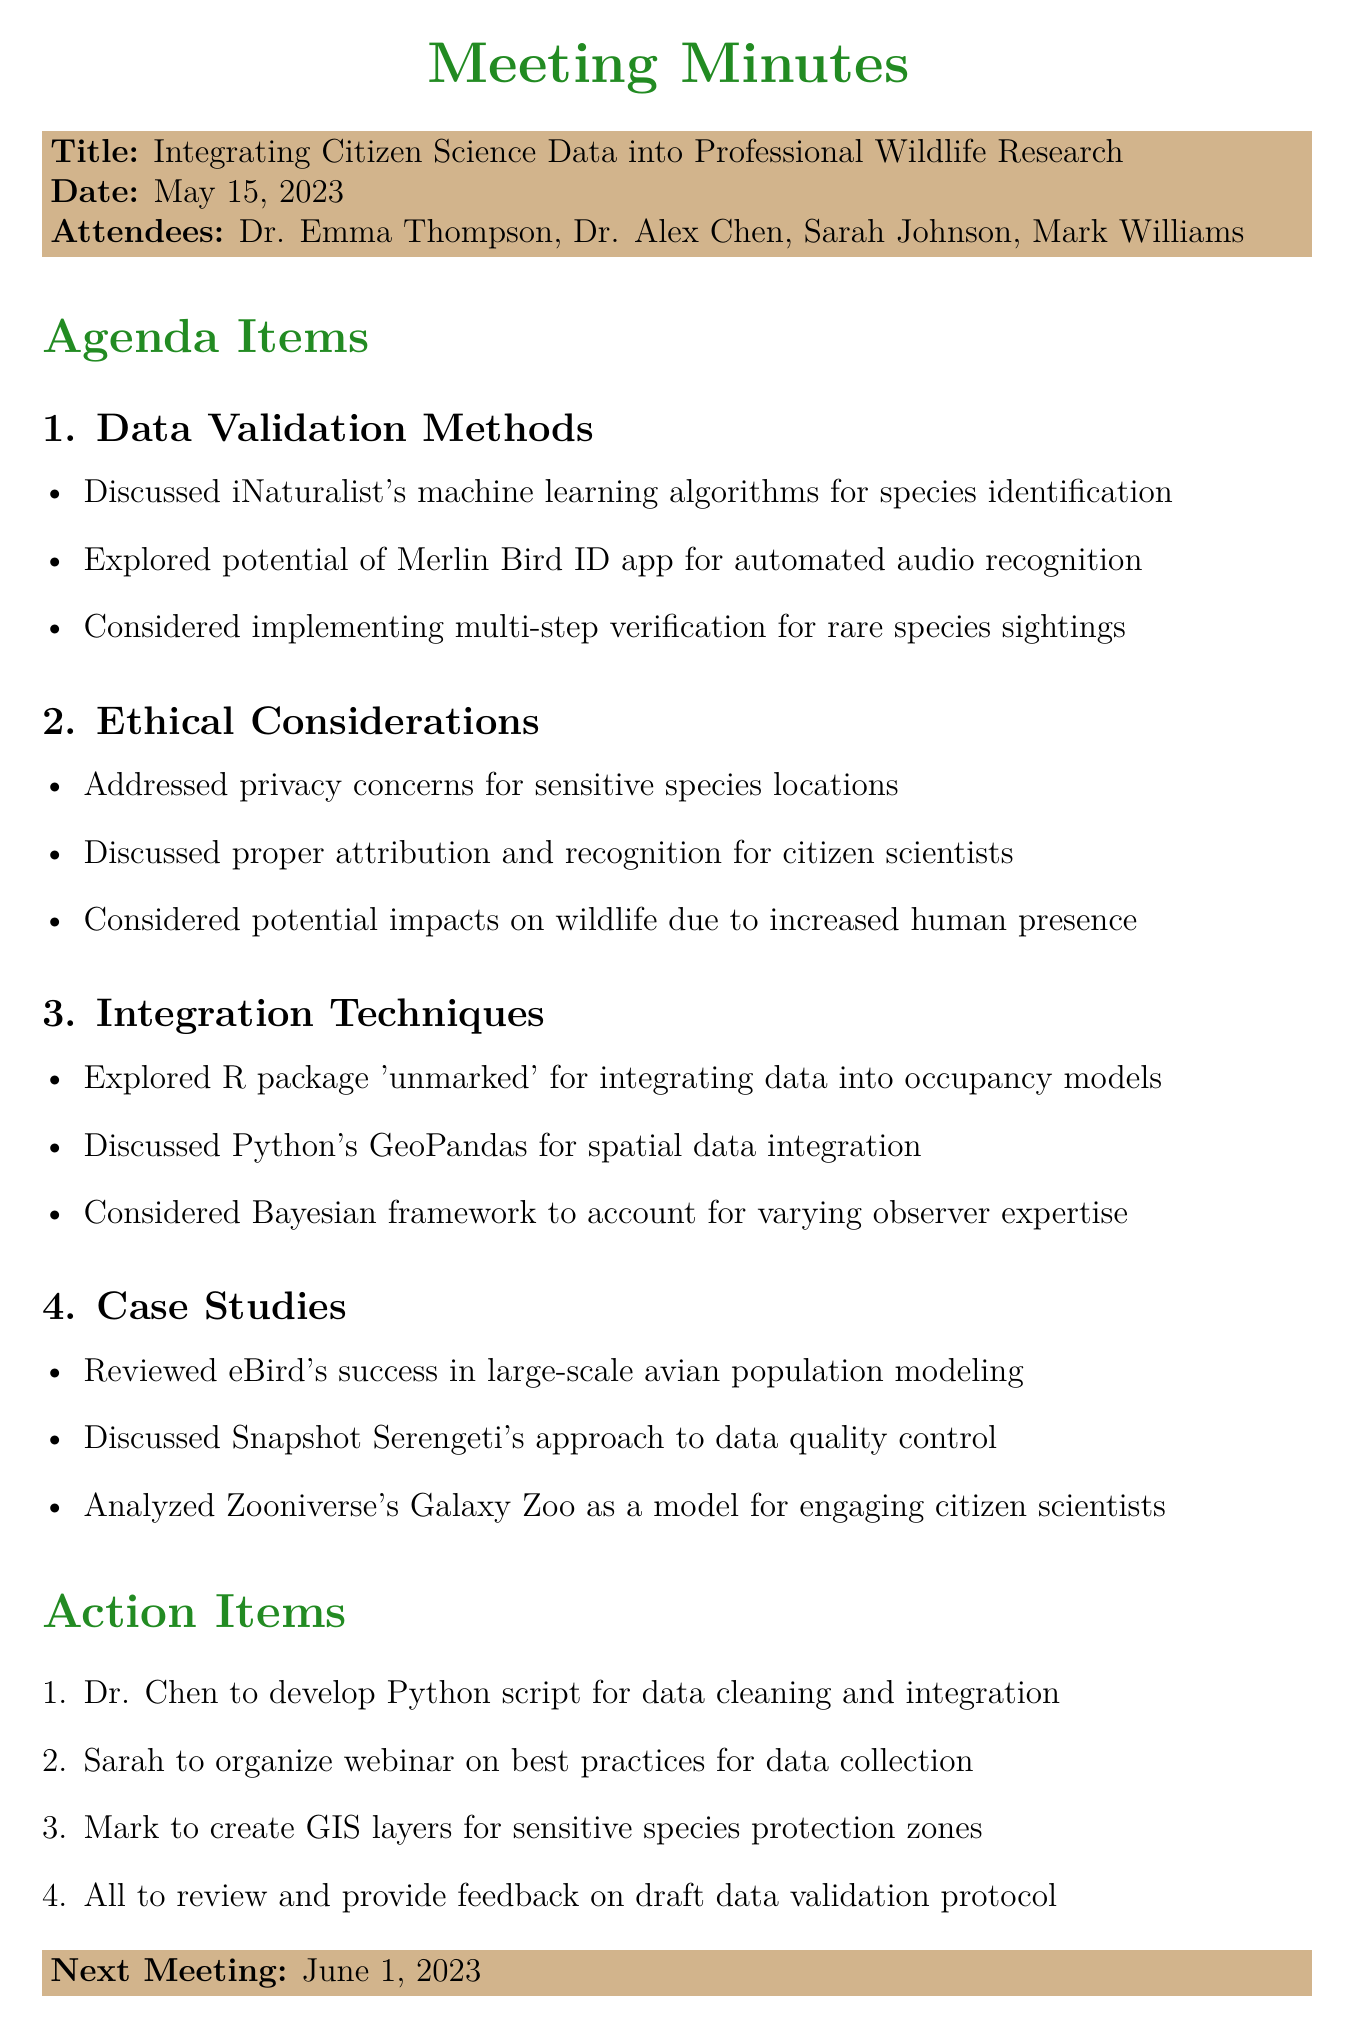What is the title of the meeting? The title of the meeting is stated at the beginning of the document.
Answer: Integrating Citizen Science Data into Professional Wildlife Research Who attended the meeting? The attendees are listed in the document, detailing all individuals present.
Answer: Dr. Emma Thompson, Dr. Alex Chen, Sarah Johnson, Mark Williams What is the date of the next meeting? The next meeting date is mentioned in the document.
Answer: June 1, 2023 Which R package was explored for data integration? The document specifies an R package considered for integration purposes.
Answer: unmarked What ethical concern was addressed regarding species locations? The minutes highlight a specific ethical issue mentioned in the discussion.
Answer: Privacy concerns for sensitive species locations Who is responsible for developing a Python script? An action item in the document assigns this task to a specific attendee.
Answer: Dr. Chen How many agenda items were discussed in total? The document outlines four distinct agenda topics that were covered.
Answer: Four What method is used for data quality control in the Snapshot Serengeti project? One of the case studies focuses on the approaches taken by a particular project.
Answer: Data quality control What is one of the methods for species recognition discussed in the meeting? The document includes potential methods mentioned for species identification.
Answer: Merlin Bird ID app 